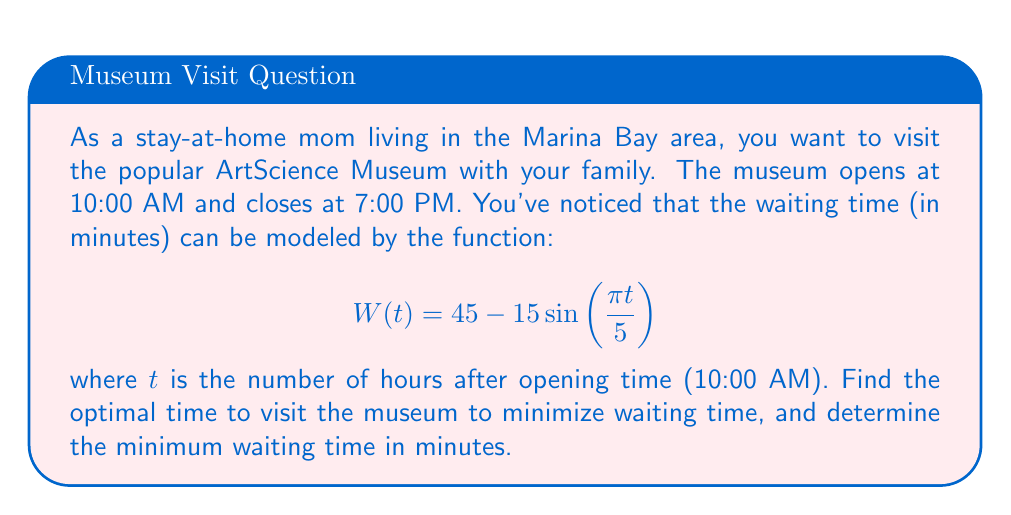Show me your answer to this math problem. To find the optimal time to visit the museum, we need to minimize the waiting time function $W(t)$. This can be done by finding the minimum value of the function within the given domain.

1. The museum is open for 9 hours (10:00 AM to 7:00 PM), so our domain is $0 \leq t \leq 9$.

2. To find the minimum, we need to find where the derivative of $W(t)$ equals zero:

   $$W'(t) = -15 \cdot \frac{\pi}{5} \cos\left(\frac{\pi t}{5}\right) = -3\pi \cos\left(\frac{\pi t}{5}\right)$$

3. Set $W'(t) = 0$:

   $$-3\pi \cos\left(\frac{\pi t}{5}\right) = 0$$
   $$\cos\left(\frac{\pi t}{5}\right) = 0$$

4. Solve for $t$:

   $$\frac{\pi t}{5} = \frac{\pi}{2} + \pi n, \text{ where } n \text{ is an integer}$$
   $$t = \frac{5}{2} + 5n$$

5. The first solution within our domain is when $n = 0$:

   $$t = \frac{5}{2} = 2.5 \text{ hours after opening}$$

6. This corresponds to 12:30 PM (2.5 hours after 10:00 AM).

7. To find the minimum waiting time, plug $t = 2.5$ into the original function:

   $$W(2.5) = 45 - 15\sin\left(\frac{\pi \cdot 2.5}{5}\right) = 45 - 15\sin\left(\frac{\pi}{2}\right) = 45 - 15 = 30 \text{ minutes}$$

Therefore, the optimal time to visit is 12:30 PM, and the minimum waiting time is 30 minutes.
Answer: Optimal time to visit: 12:30 PM
Minimum waiting time: 30 minutes 